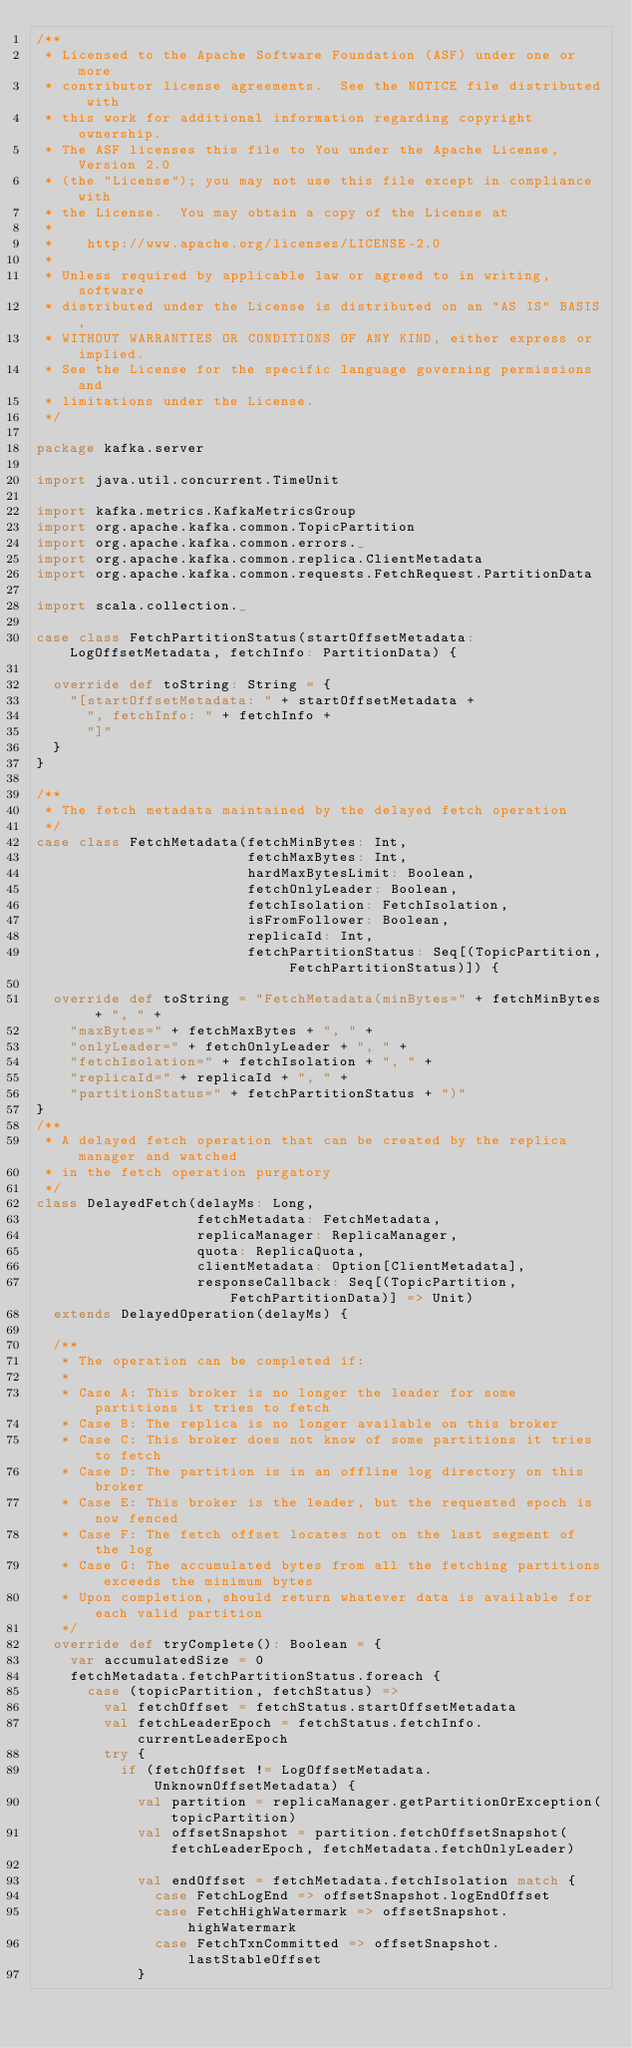Convert code to text. <code><loc_0><loc_0><loc_500><loc_500><_Scala_>/**
 * Licensed to the Apache Software Foundation (ASF) under one or more
 * contributor license agreements.  See the NOTICE file distributed with
 * this work for additional information regarding copyright ownership.
 * The ASF licenses this file to You under the Apache License, Version 2.0
 * (the "License"); you may not use this file except in compliance with
 * the License.  You may obtain a copy of the License at
 *
 *    http://www.apache.org/licenses/LICENSE-2.0
 *
 * Unless required by applicable law or agreed to in writing, software
 * distributed under the License is distributed on an "AS IS" BASIS,
 * WITHOUT WARRANTIES OR CONDITIONS OF ANY KIND, either express or implied.
 * See the License for the specific language governing permissions and
 * limitations under the License.
 */

package kafka.server

import java.util.concurrent.TimeUnit

import kafka.metrics.KafkaMetricsGroup
import org.apache.kafka.common.TopicPartition
import org.apache.kafka.common.errors._
import org.apache.kafka.common.replica.ClientMetadata
import org.apache.kafka.common.requests.FetchRequest.PartitionData

import scala.collection._

case class FetchPartitionStatus(startOffsetMetadata: LogOffsetMetadata, fetchInfo: PartitionData) {

  override def toString: String = {
    "[startOffsetMetadata: " + startOffsetMetadata +
      ", fetchInfo: " + fetchInfo +
      "]"
  }
}

/**
 * The fetch metadata maintained by the delayed fetch operation
 */
case class FetchMetadata(fetchMinBytes: Int,
                         fetchMaxBytes: Int,
                         hardMaxBytesLimit: Boolean,
                         fetchOnlyLeader: Boolean,
                         fetchIsolation: FetchIsolation,
                         isFromFollower: Boolean,
                         replicaId: Int,
                         fetchPartitionStatus: Seq[(TopicPartition, FetchPartitionStatus)]) {

  override def toString = "FetchMetadata(minBytes=" + fetchMinBytes + ", " +
    "maxBytes=" + fetchMaxBytes + ", " +
    "onlyLeader=" + fetchOnlyLeader + ", " +
    "fetchIsolation=" + fetchIsolation + ", " +
    "replicaId=" + replicaId + ", " +
    "partitionStatus=" + fetchPartitionStatus + ")"
}
/**
 * A delayed fetch operation that can be created by the replica manager and watched
 * in the fetch operation purgatory
 */
class DelayedFetch(delayMs: Long,
                   fetchMetadata: FetchMetadata,
                   replicaManager: ReplicaManager,
                   quota: ReplicaQuota,
                   clientMetadata: Option[ClientMetadata],
                   responseCallback: Seq[(TopicPartition, FetchPartitionData)] => Unit)
  extends DelayedOperation(delayMs) {

  /**
   * The operation can be completed if:
   *
   * Case A: This broker is no longer the leader for some partitions it tries to fetch
   * Case B: The replica is no longer available on this broker
   * Case C: This broker does not know of some partitions it tries to fetch
   * Case D: The partition is in an offline log directory on this broker
   * Case E: This broker is the leader, but the requested epoch is now fenced
   * Case F: The fetch offset locates not on the last segment of the log
   * Case G: The accumulated bytes from all the fetching partitions exceeds the minimum bytes
   * Upon completion, should return whatever data is available for each valid partition
   */
  override def tryComplete(): Boolean = {
    var accumulatedSize = 0
    fetchMetadata.fetchPartitionStatus.foreach {
      case (topicPartition, fetchStatus) =>
        val fetchOffset = fetchStatus.startOffsetMetadata
        val fetchLeaderEpoch = fetchStatus.fetchInfo.currentLeaderEpoch
        try {
          if (fetchOffset != LogOffsetMetadata.UnknownOffsetMetadata) {
            val partition = replicaManager.getPartitionOrException(topicPartition)
            val offsetSnapshot = partition.fetchOffsetSnapshot(fetchLeaderEpoch, fetchMetadata.fetchOnlyLeader)

            val endOffset = fetchMetadata.fetchIsolation match {
              case FetchLogEnd => offsetSnapshot.logEndOffset
              case FetchHighWatermark => offsetSnapshot.highWatermark
              case FetchTxnCommitted => offsetSnapshot.lastStableOffset
            }
</code> 